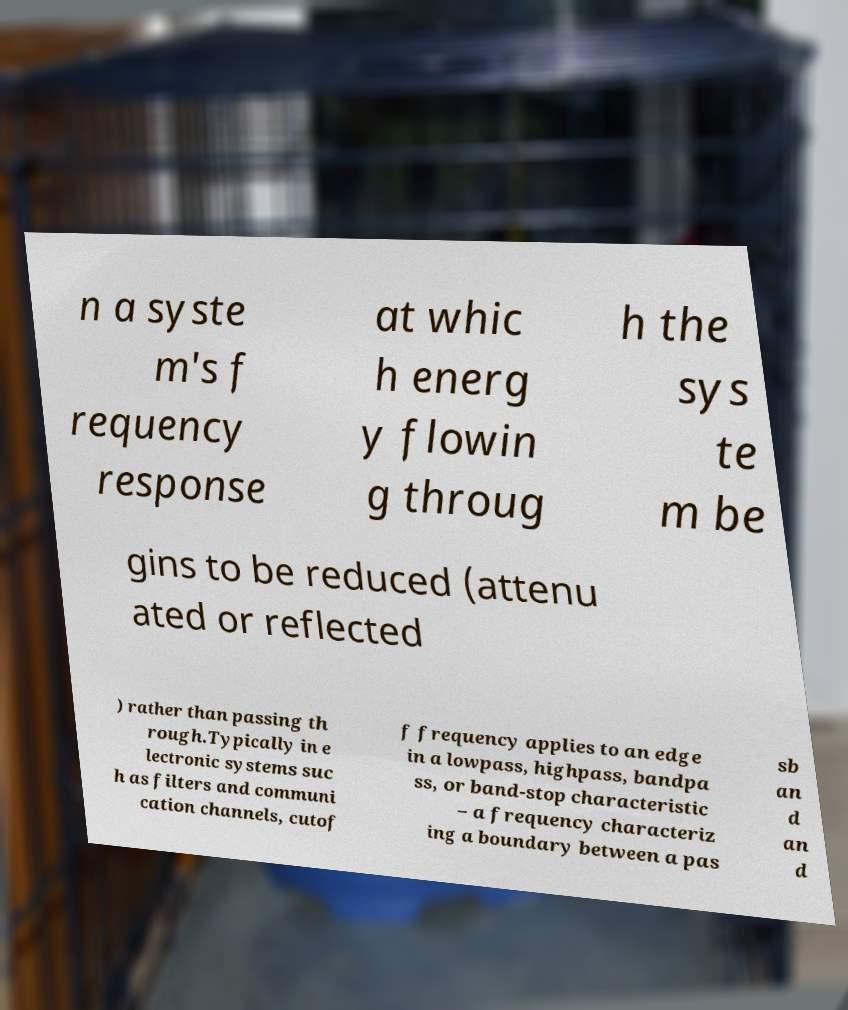Could you extract and type out the text from this image? n a syste m's f requency response at whic h energ y flowin g throug h the sys te m be gins to be reduced (attenu ated or reflected ) rather than passing th rough.Typically in e lectronic systems suc h as filters and communi cation channels, cutof f frequency applies to an edge in a lowpass, highpass, bandpa ss, or band-stop characteristic – a frequency characteriz ing a boundary between a pas sb an d an d 